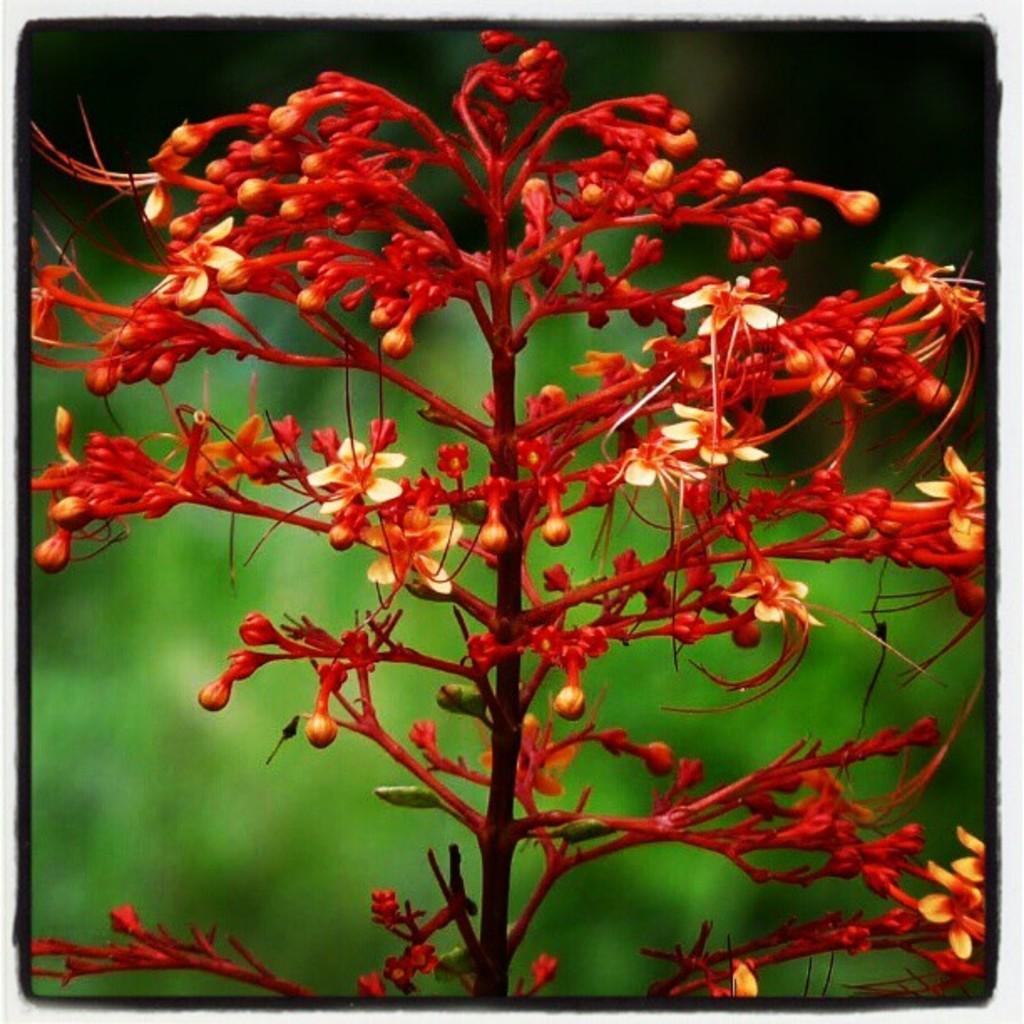Can you describe this image briefly? In this image I can see few flowers in red color and I can see the green color background. 